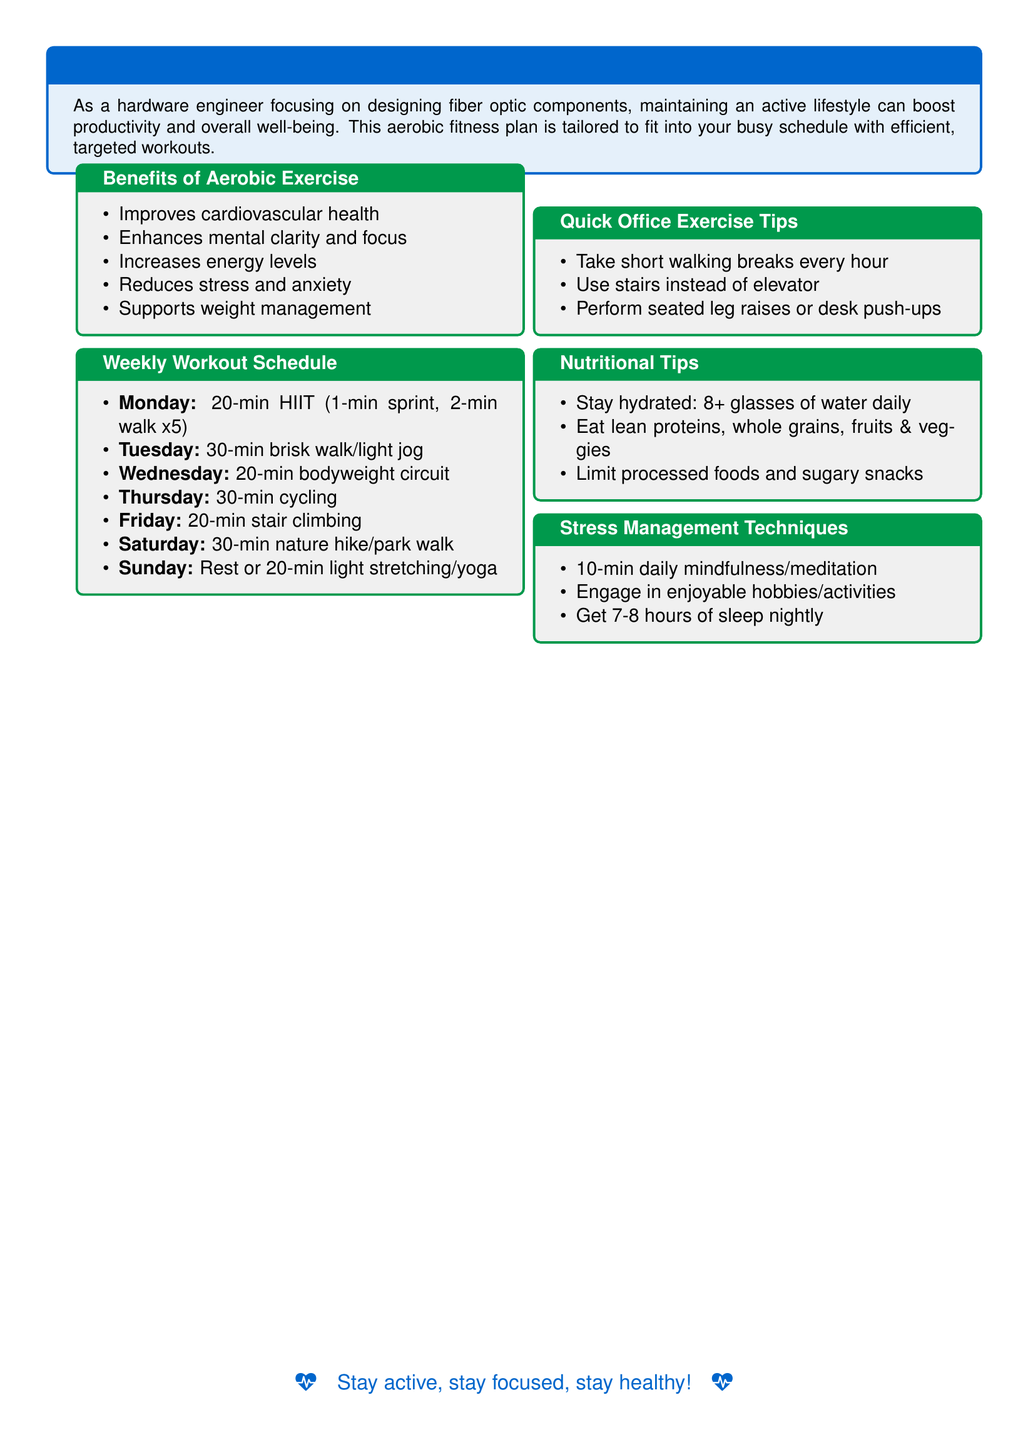What is the duration of the HIIT workout on Monday? The HIIT workout on Monday is a total of 20 minutes long as mentioned in the weekly workout schedule.
Answer: 20-min What type of exercise is suggested for Saturday? The Saturday workout suggests a nature hike or park walk as indicated in the weekly workout schedule.
Answer: nature hike/park walk How many minutes should be dedicated to the cycling session on Thursday? The cycling session on Thursday is to be done for 30 minutes as specified in the weekly workout schedule.
Answer: 30-min What is one of the stress management techniques mentioned? One of the stress management techniques includes engaging in enjoyable hobbies, outlined in the stress management techniques section.
Answer: enjoyable hobbies/activities What is recommended to limit in the Nutritional Tips section? The Nutritional Tips section advises limiting processed foods and sugary snacks.
Answer: processed foods and sugary snacks How many hours of sleep are suggested for nightly rest? It is suggested to get 7-8 hours of sleep nightly according to the stress management techniques.
Answer: 7-8 hours Which exercise is recommended for Tuesday? The recommended exercise for Tuesday is a brisk walk or light jog.
Answer: 30-min brisk walk/light jog What type of drinks should be consumed daily as per nutritional tips? The Nutritional Tips section mentions staying hydrated, which includes consuming water.
Answer: water 